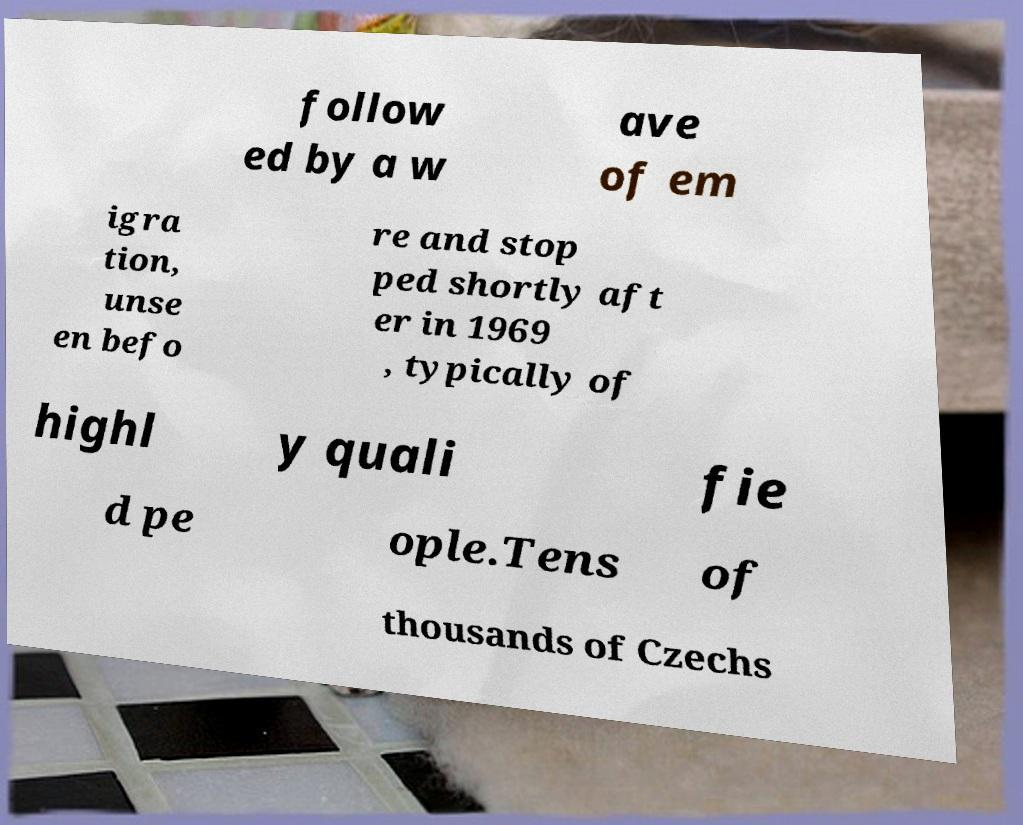Please identify and transcribe the text found in this image. follow ed by a w ave of em igra tion, unse en befo re and stop ped shortly aft er in 1969 , typically of highl y quali fie d pe ople.Tens of thousands of Czechs 